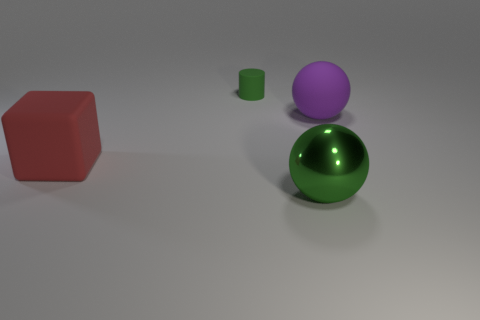Can you describe the positioning of the objects in the image? In the image, there is a large red cube positioned to the far left. Centered in the image is a large green sphere, and to the right of the sphere, there is a smaller green cylinder. Behind and above the sphere, there is a medium-sized purple sphere. 